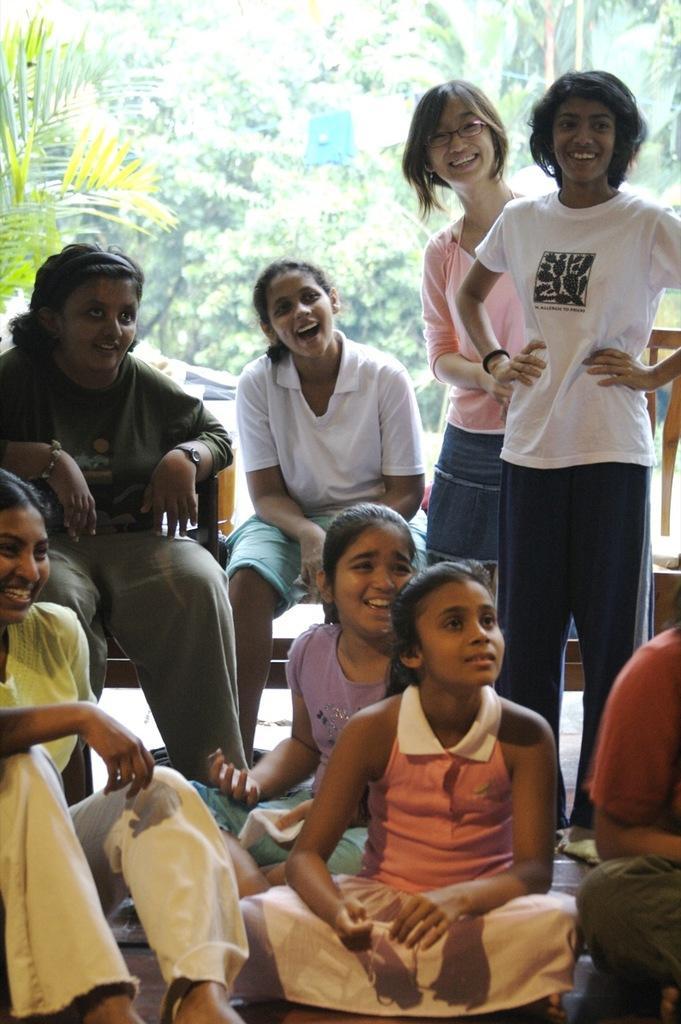In one or two sentences, can you explain what this image depicts? There are children in different color dresses, smiling. Some of them are sitting. In the background, there are trees. 